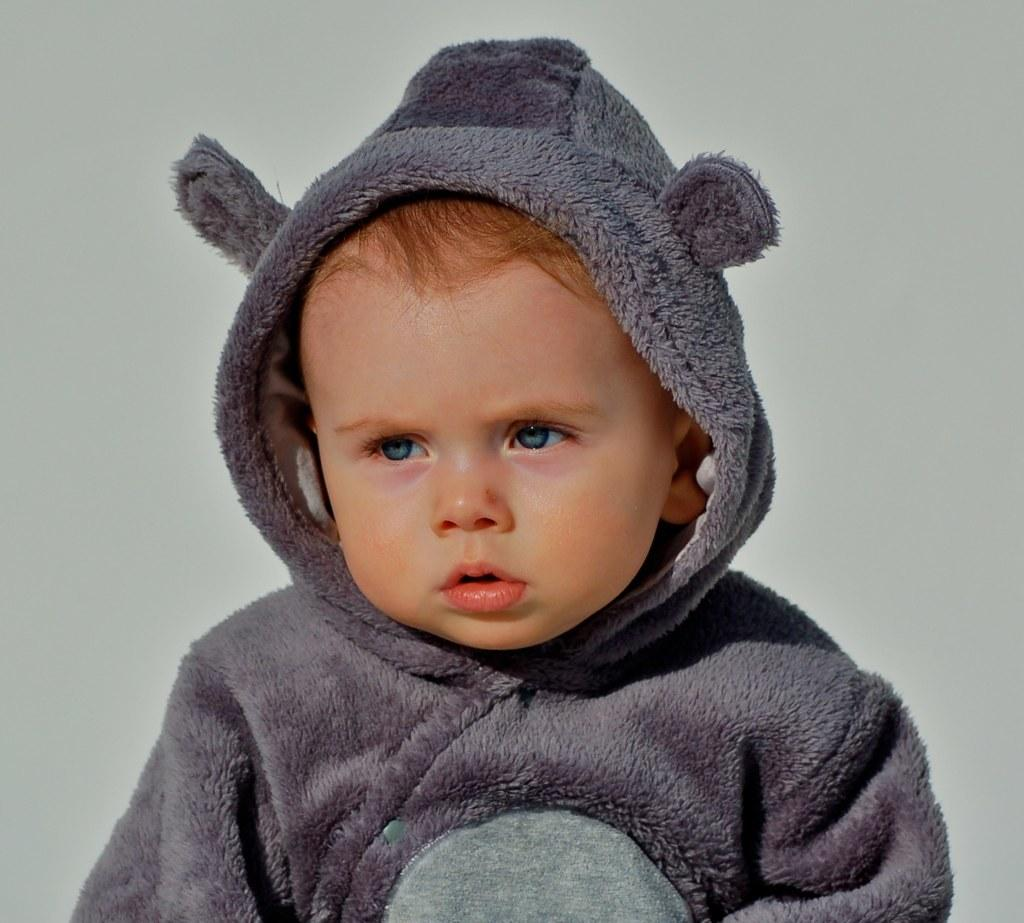Who is the main subject in the image? There is a boy in the image. What is the boy wearing in the image? The boy is wearing a grey color hoodie. What type of government does the frog in the image represent? There is no frog present in the image, so it cannot represent any type of government. 